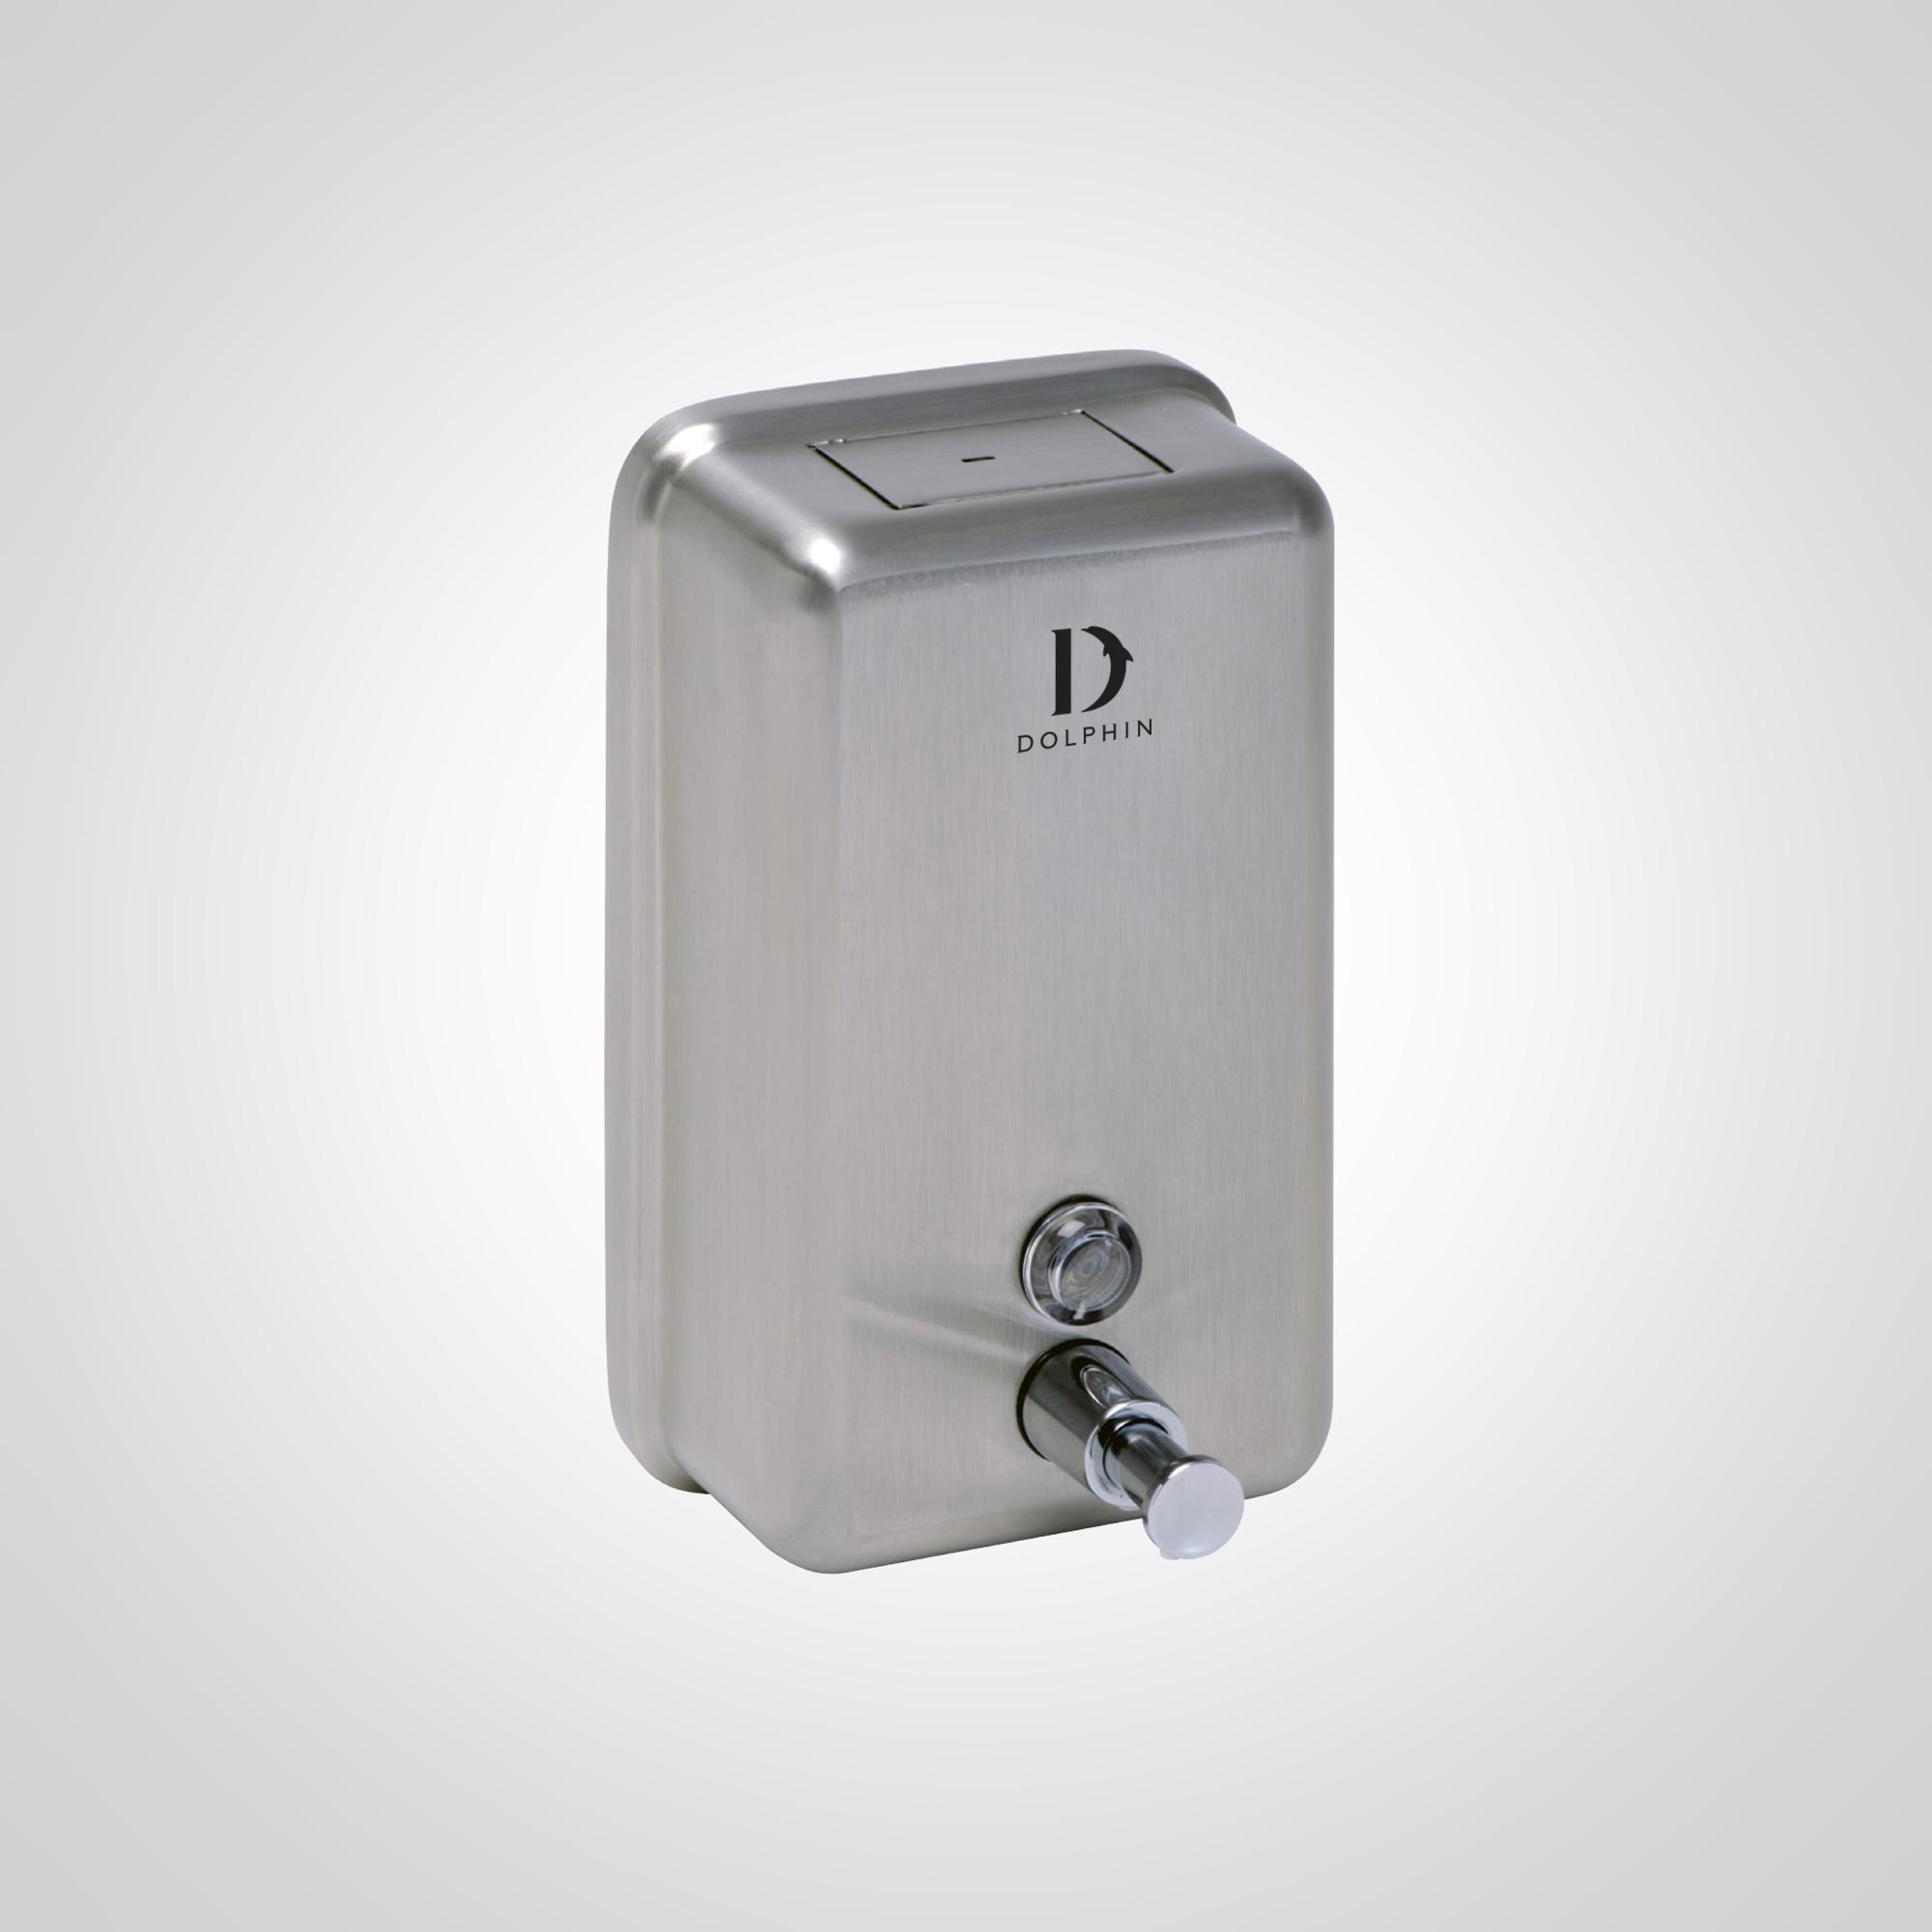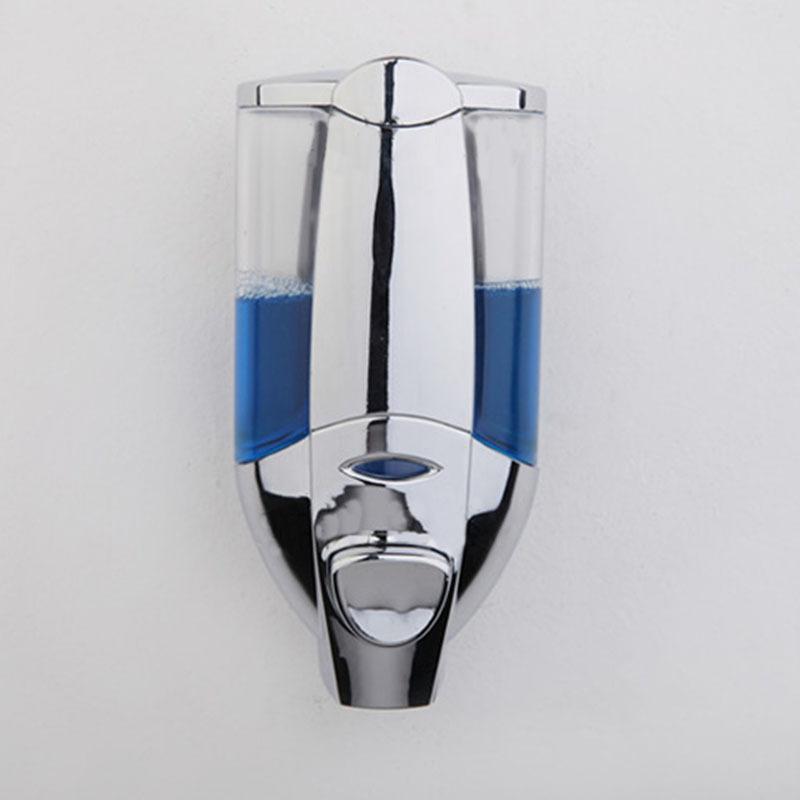The first image is the image on the left, the second image is the image on the right. Examine the images to the left and right. Is the description "There are exactly two all metal dispensers." accurate? Answer yes or no. No. The first image is the image on the left, the second image is the image on the right. Evaluate the accuracy of this statement regarding the images: "there is a soap dispenser with a thumb pushing the dispenser plunger". Is it true? Answer yes or no. No. 